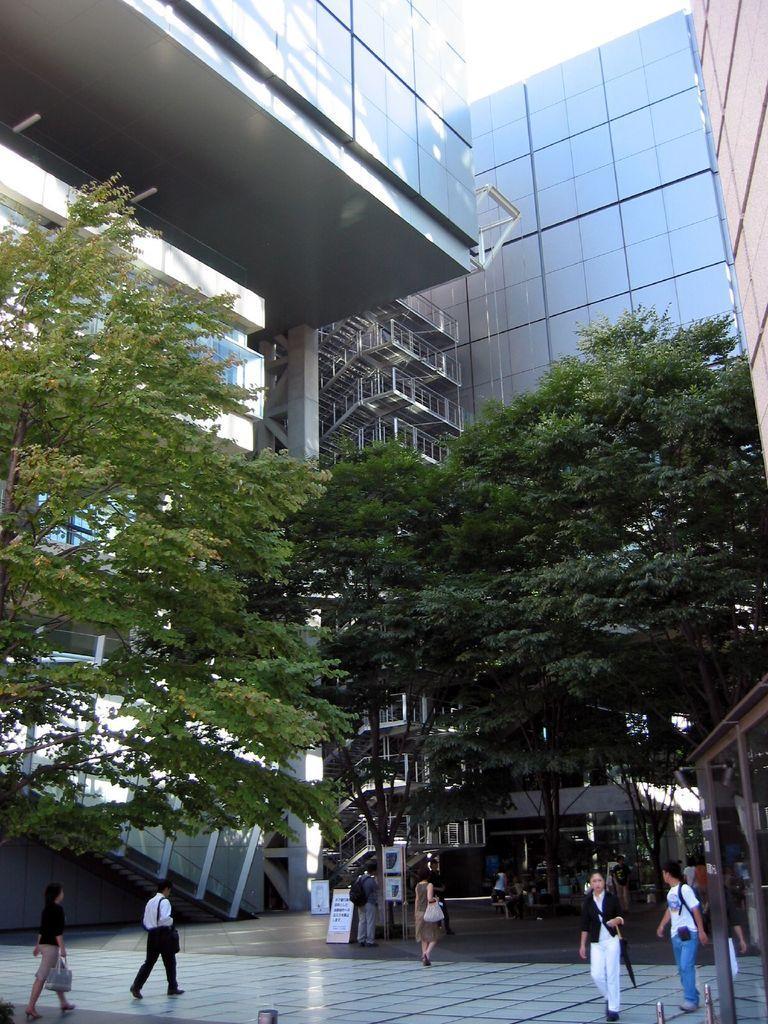Please provide a concise description of this image. In this image I can see a building , in front of the building I can see persons walking and at the top I can see the sky. 